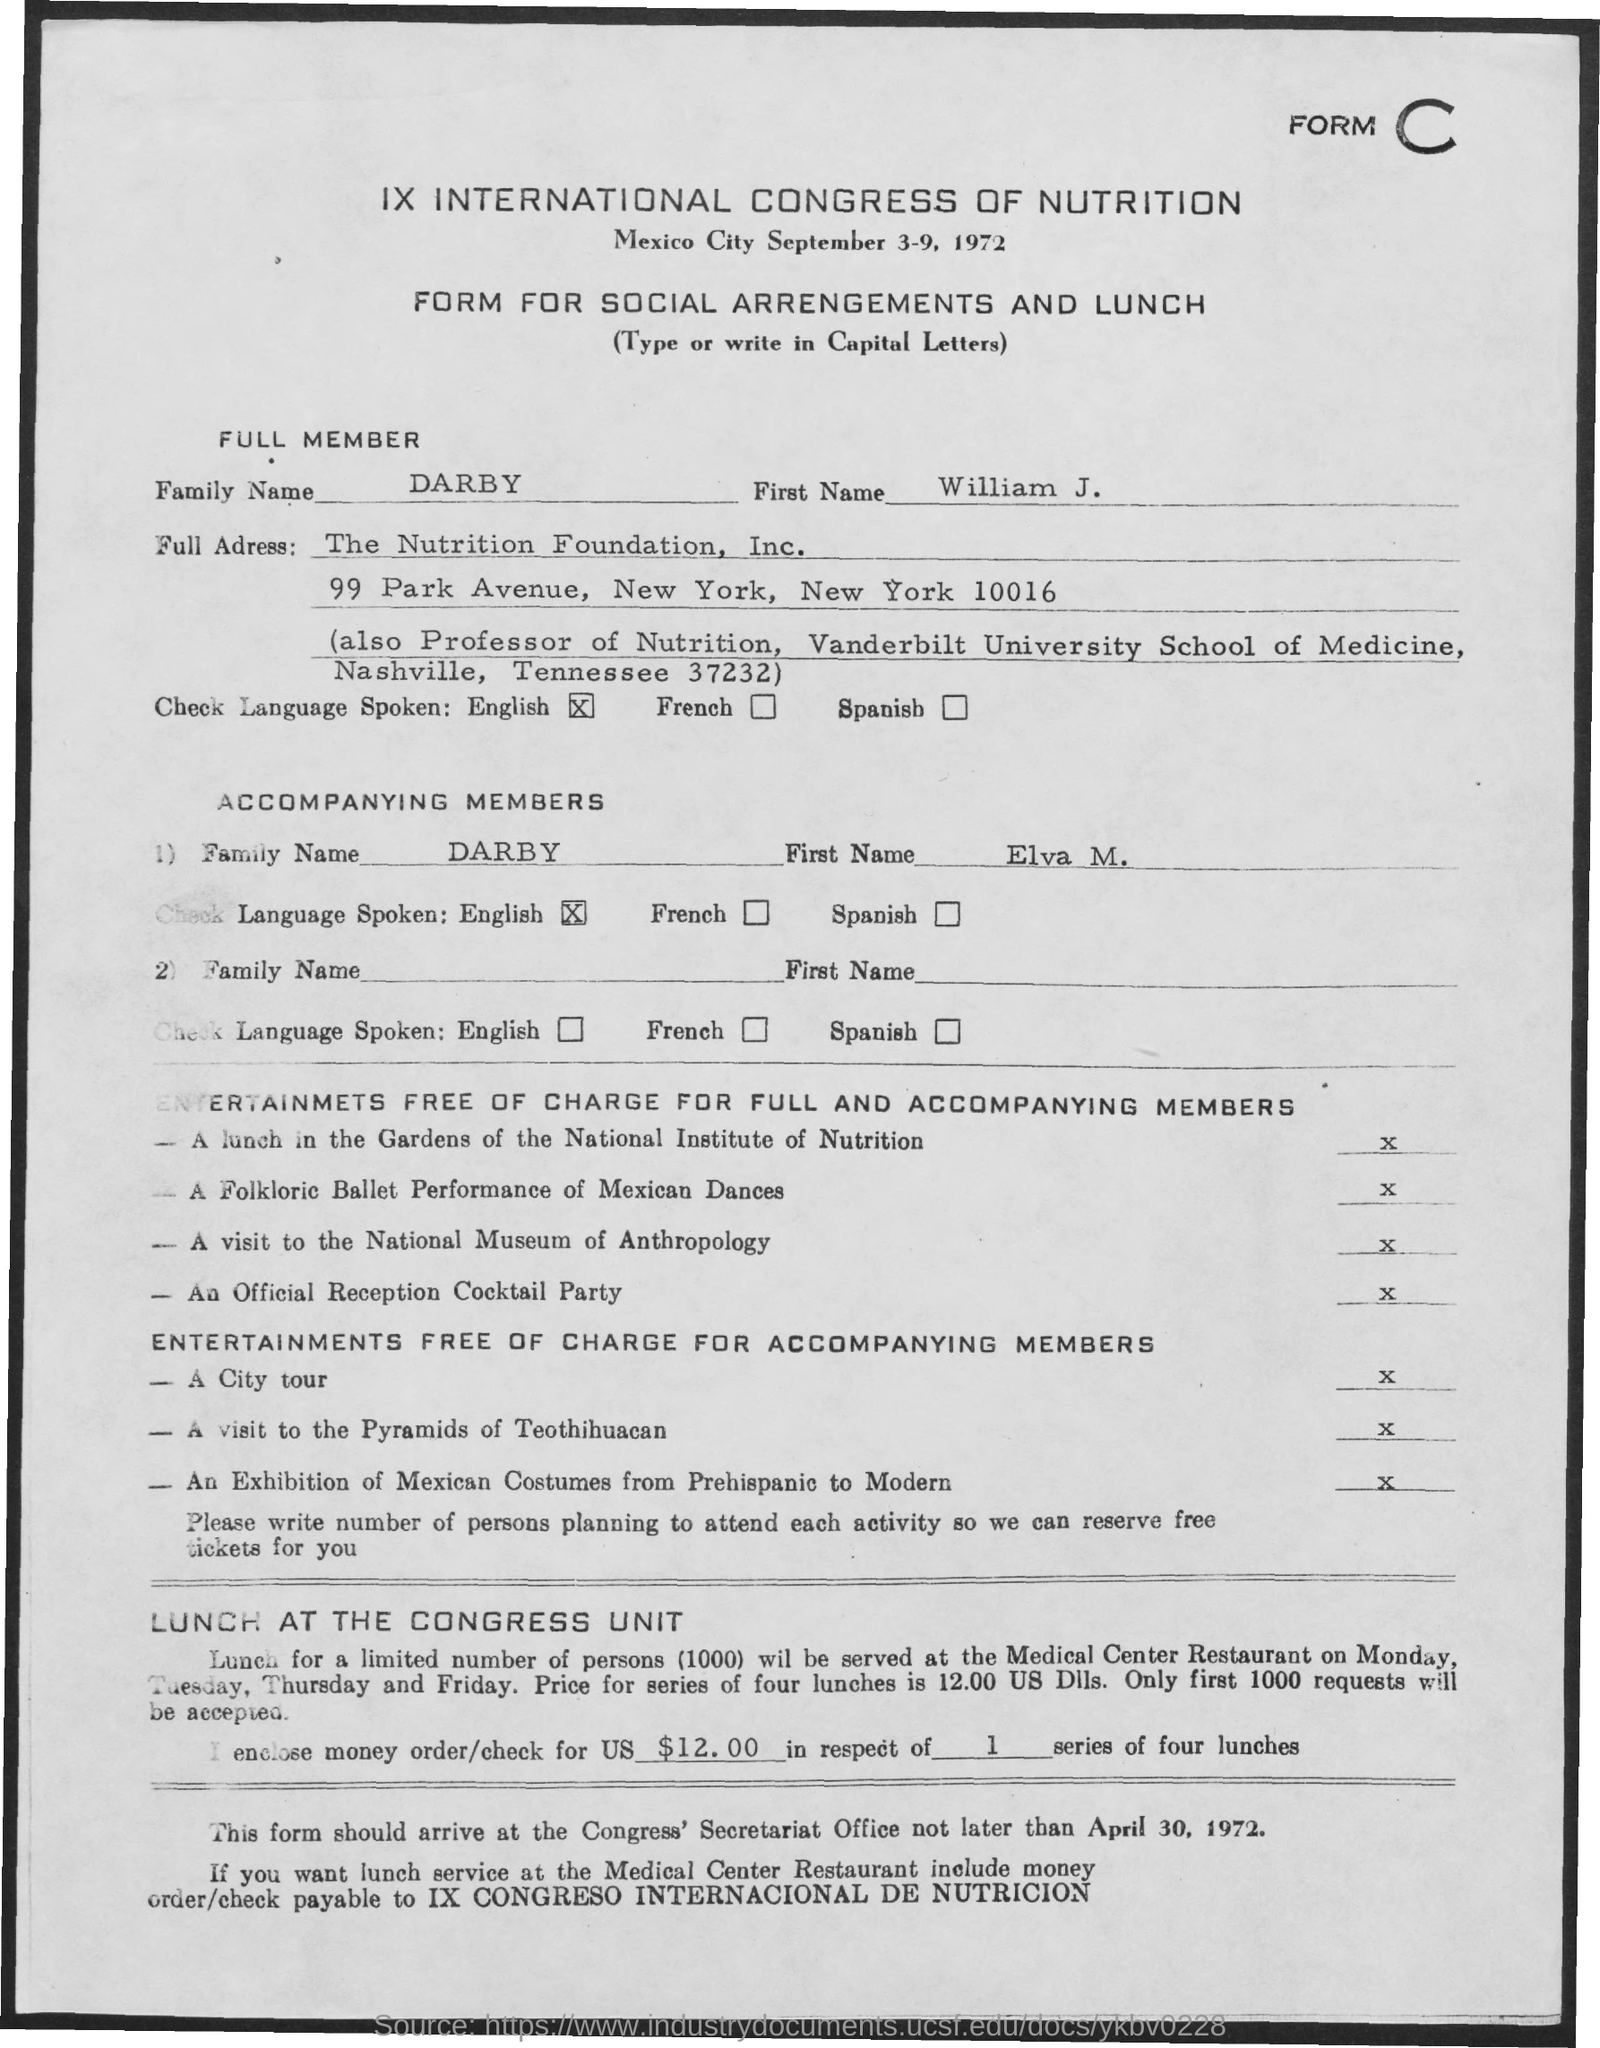List a handful of essential elements in this visual. The accompanying member's first name is "ELVA M...". This is a form for social arrangements and lunch. William J. Darby speaks English. The full member's first name is WILLIAM J... At THE NUTRITION FOUNDATION, INC., William J. Darby is employed. 